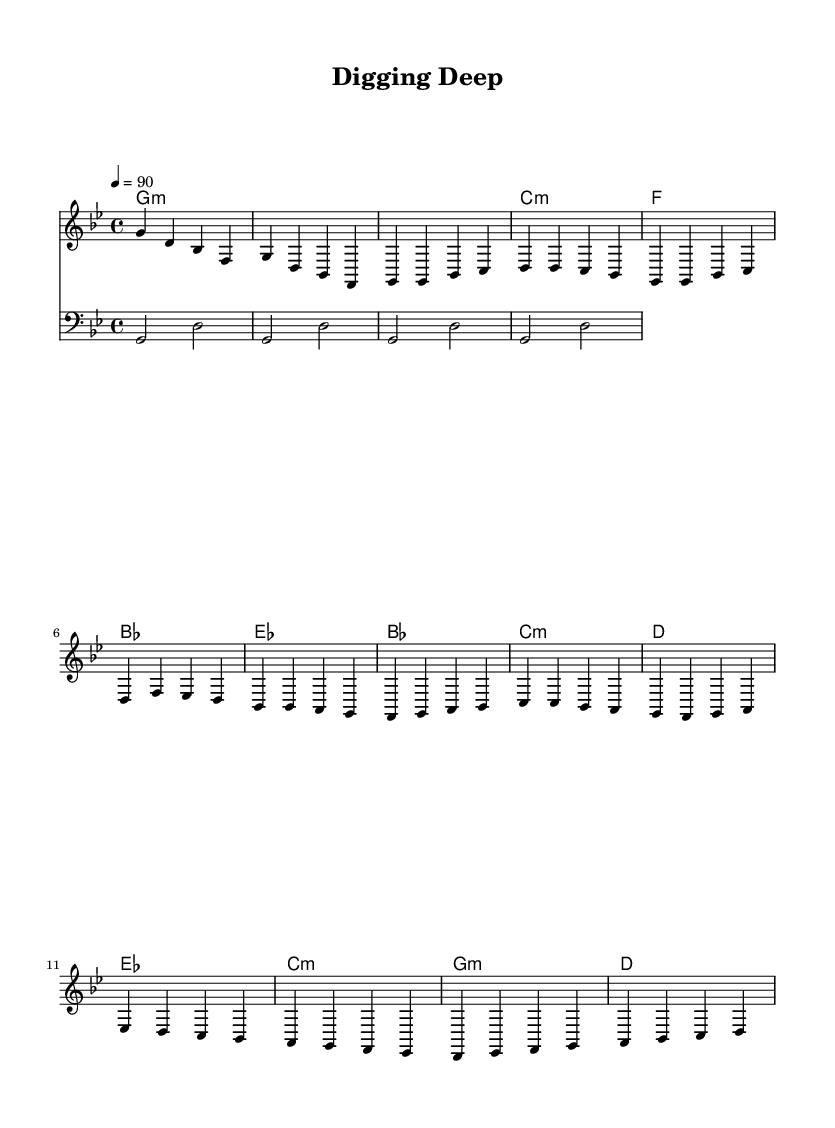What is the key signature of this music? The key signature is G minor, which typically has two flats (B flat and E flat). This can be determined from the key indicated in the global settings.
Answer: G minor What is the time signature of this piece? The time signature is 4/4, which means there are four beats in each measure. This is indicated in the global settings of the music.
Answer: 4/4 What is the tempo marking for this piece? The tempo marking indicates a speed of 90 beats per minute. This is also specified in the global settings by the tempo command.
Answer: 90 How many measures are in the introduction section? The introduction consists of 2 measures, as indicated by the two groups of notes that follow one after the other in the music notation under the Intro section.
Answer: 2 What chord follows the first measure in the verse section? The first measure of the verse section is followed by a C minor chord. This is identified in the chord changes specified in the harmonies section in connection to the melody.
Answer: C minor What is the highest note in the melody? The highest note in the melody is D. This can be identified by analyzing the pitches present in the melody line, with D appearing as the highest note.
Answer: D How does the chorus differ from the verse in terms of harmonic structure? The chorus introduces chords that include E flat major and A flat, while the verse uses F major and B flat. This can be seen by evaluating the harmonic progression in both sections.
Answer: Different chords 